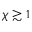<formula> <loc_0><loc_0><loc_500><loc_500>\chi \gtrsim 1</formula> 